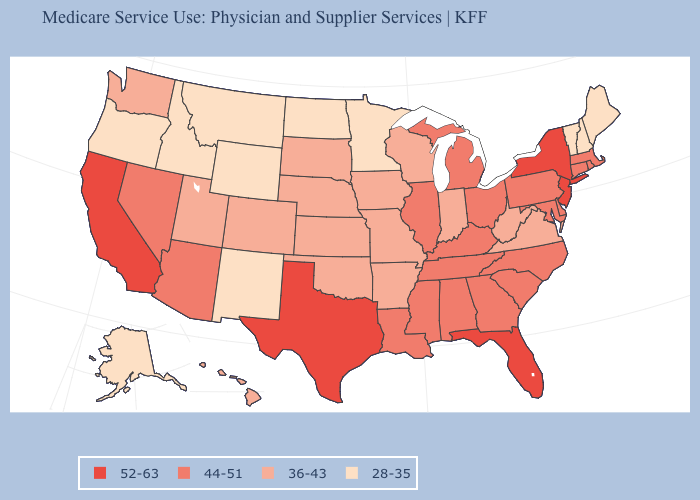What is the lowest value in the USA?
Concise answer only. 28-35. What is the lowest value in the USA?
Short answer required. 28-35. Does Montana have the lowest value in the USA?
Give a very brief answer. Yes. What is the value of Mississippi?
Keep it brief. 44-51. What is the value of Michigan?
Short answer required. 44-51. Does Delaware have a higher value than Arizona?
Be succinct. No. What is the highest value in the USA?
Concise answer only. 52-63. What is the value of Rhode Island?
Write a very short answer. 44-51. Name the states that have a value in the range 36-43?
Keep it brief. Arkansas, Colorado, Hawaii, Indiana, Iowa, Kansas, Missouri, Nebraska, Oklahoma, South Dakota, Utah, Virginia, Washington, West Virginia, Wisconsin. Among the states that border Illinois , which have the lowest value?
Give a very brief answer. Indiana, Iowa, Missouri, Wisconsin. Name the states that have a value in the range 52-63?
Keep it brief. California, Florida, New Jersey, New York, Texas. What is the value of Ohio?
Keep it brief. 44-51. Name the states that have a value in the range 52-63?
Short answer required. California, Florida, New Jersey, New York, Texas. What is the lowest value in the USA?
Be succinct. 28-35. Which states have the highest value in the USA?
Short answer required. California, Florida, New Jersey, New York, Texas. 